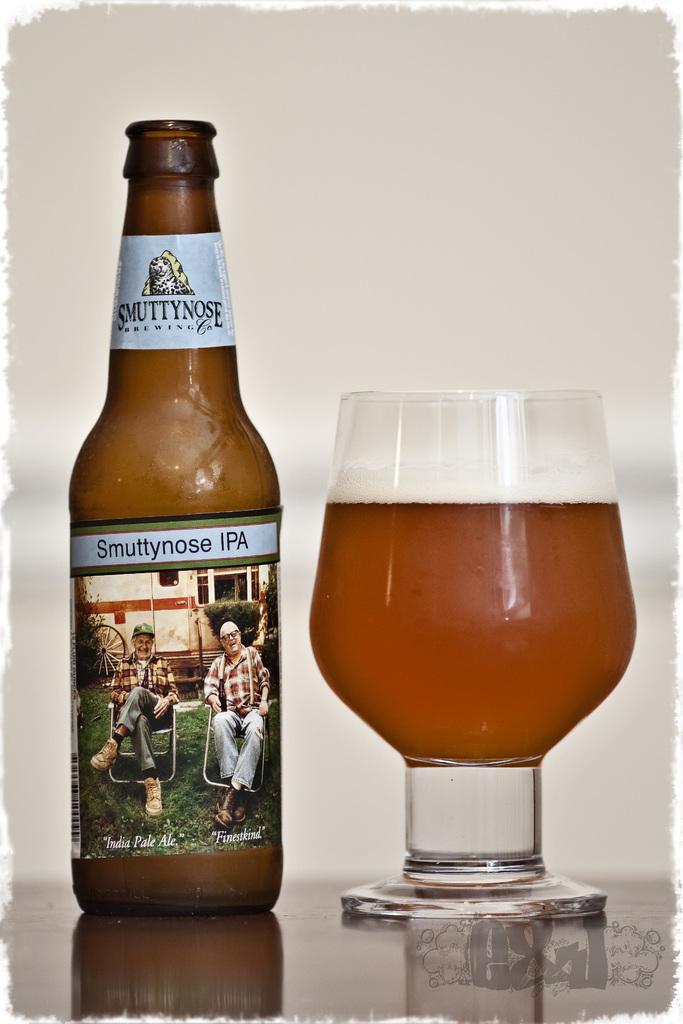What is on the table in the image? There is a wine bottle with a label and lid, as well as a glass of wine on the table. What is the wine bottle's condition? The wine bottle has a label and lid. What is the purpose of the glass in the image? The glass is for holding wine. What can be seen in the background of the image? There is a wall in the background of the image. What type of picture is hanging on the wall in the image? There is no picture hanging on the wall in the image; only a wall is visible in the background. What material is the lead used for in the image? There is no lead present in the image. 